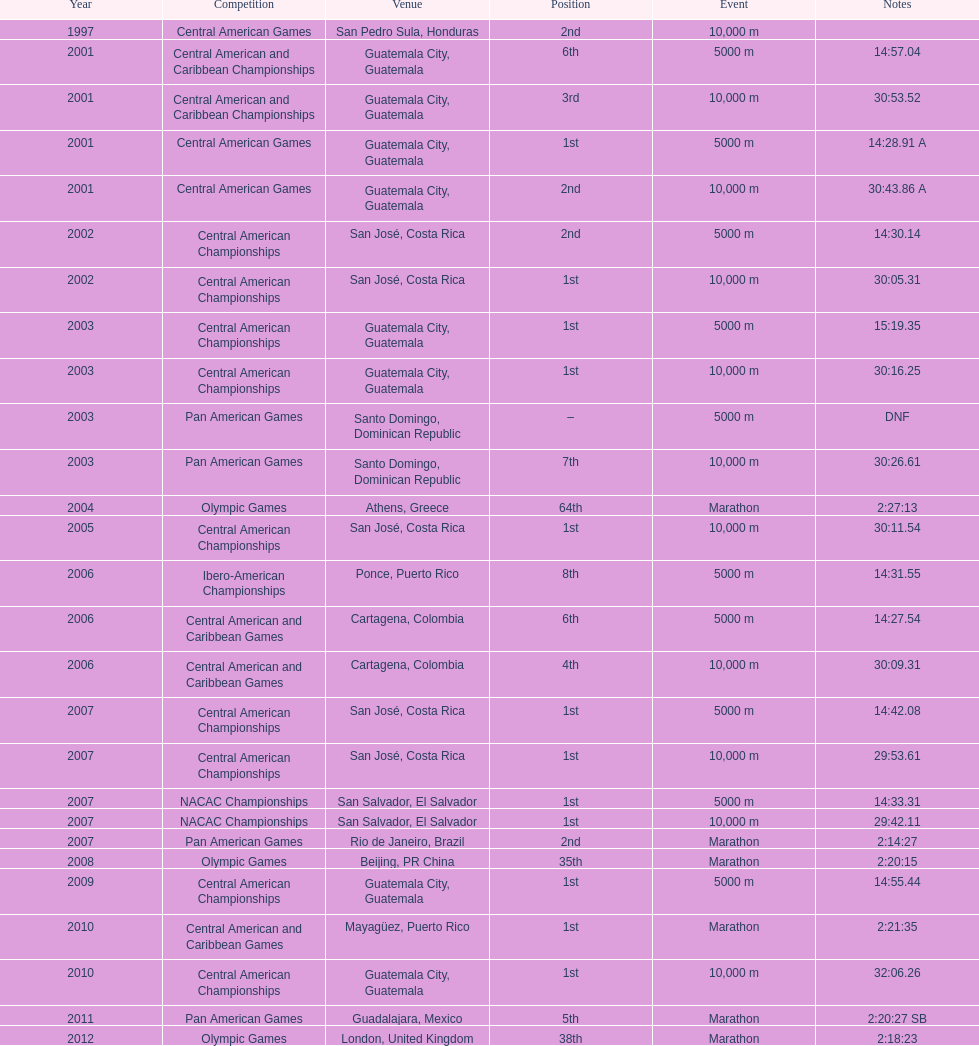Which game occupied the 2nd spot in the 2007 rankings? Pan American Games. 